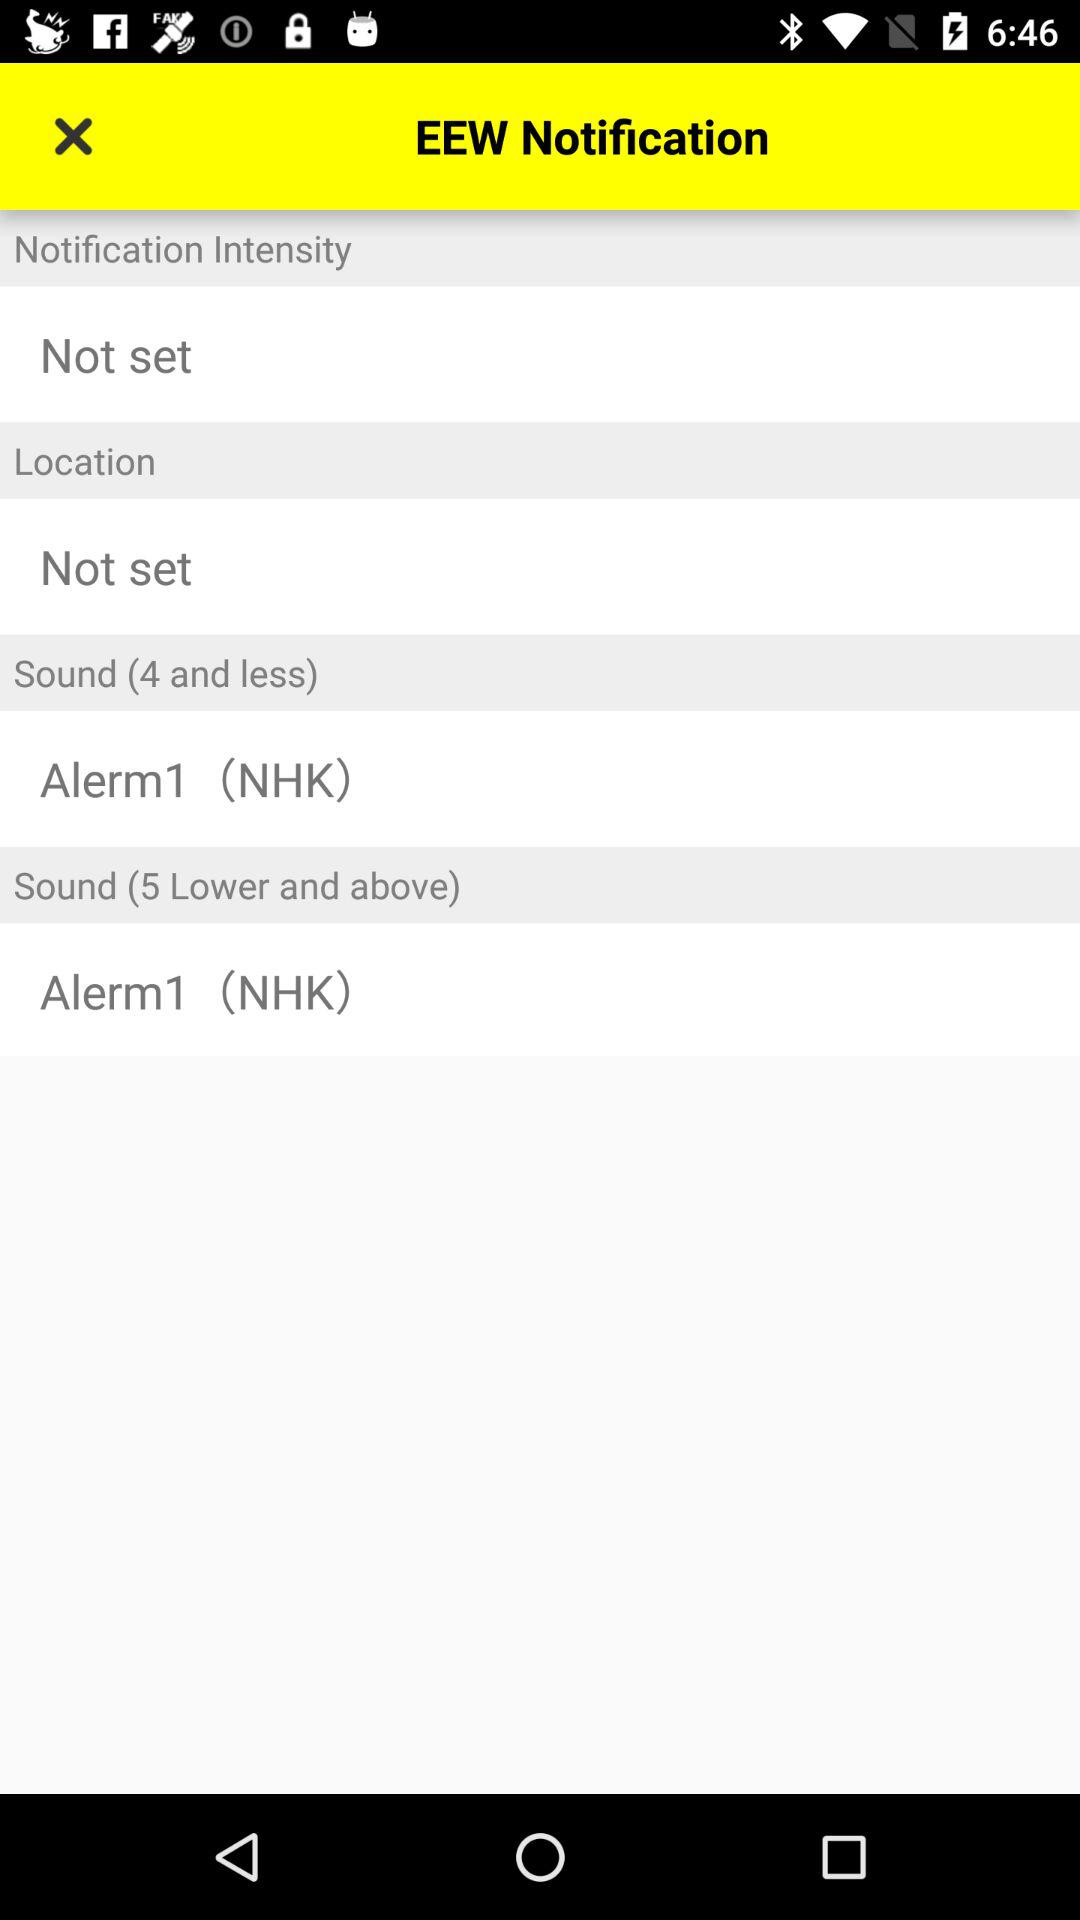How many items have the text 'NHK' in them?
Answer the question using a single word or phrase. 2 